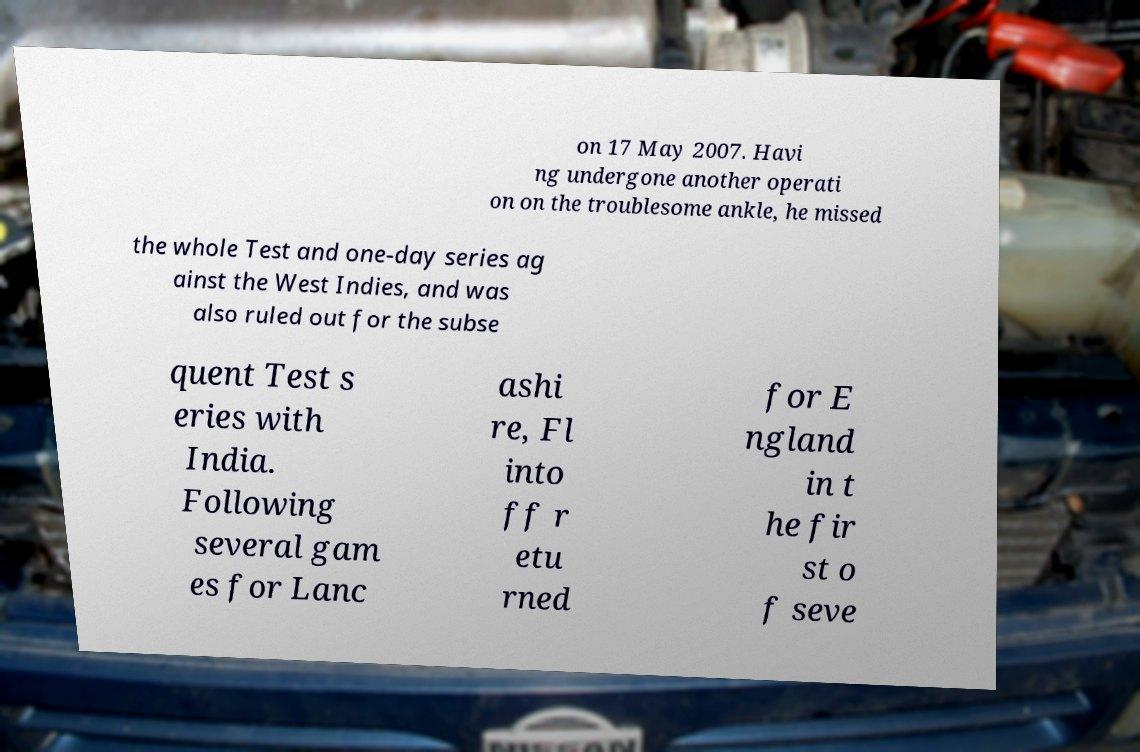Can you accurately transcribe the text from the provided image for me? on 17 May 2007. Havi ng undergone another operati on on the troublesome ankle, he missed the whole Test and one-day series ag ainst the West Indies, and was also ruled out for the subse quent Test s eries with India. Following several gam es for Lanc ashi re, Fl into ff r etu rned for E ngland in t he fir st o f seve 